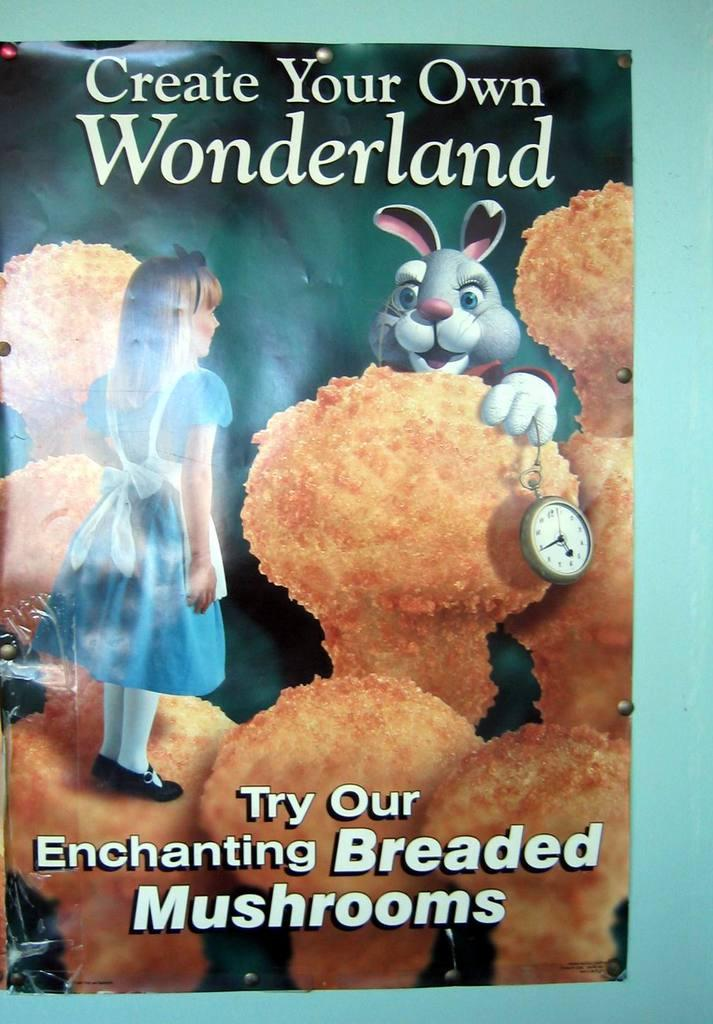<image>
Relay a brief, clear account of the picture shown. An ad for breaded mushrooms has a picture of a rabbit on it. 